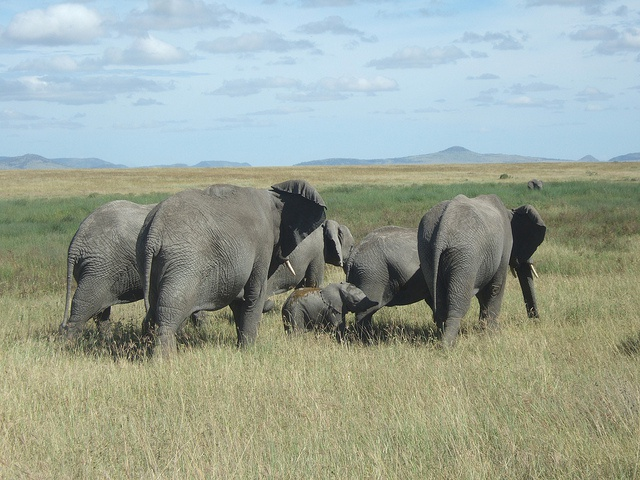Describe the objects in this image and their specific colors. I can see elephant in lightblue, gray, darkgray, and black tones, elephant in lightblue, black, gray, and darkgray tones, elephant in lightblue, gray, darkgray, and black tones, elephant in lightblue, gray, black, and darkgray tones, and elephant in lightblue, gray, black, and darkgray tones in this image. 